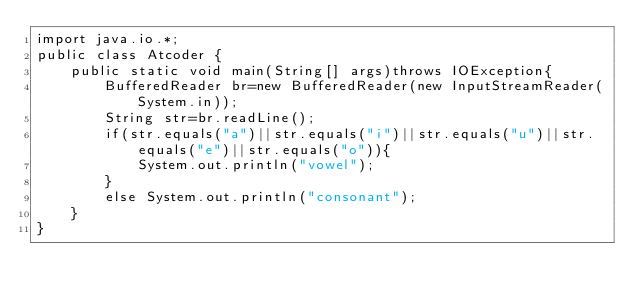Convert code to text. <code><loc_0><loc_0><loc_500><loc_500><_Java_>import java.io.*;
public class Atcoder {
	public static void main(String[] args)throws IOException{
		BufferedReader br=new BufferedReader(new InputStreamReader(System.in));
		String str=br.readLine();
		if(str.equals("a")||str.equals("i")||str.equals("u")||str.equals("e")||str.equals("o")){
			System.out.println("vowel");
		}
		else System.out.println("consonant");
	}
}</code> 